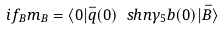Convert formula to latex. <formula><loc_0><loc_0><loc_500><loc_500>i f _ { B } m _ { B } = \langle 0 | \bar { q } ( 0 ) \ s h { n } \gamma _ { 5 } b ( 0 ) | \bar { B } \rangle</formula> 